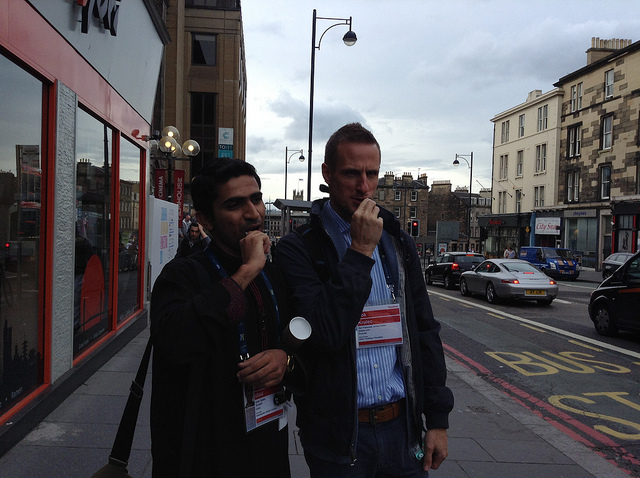<image>What is sold at the bageri? It is not sure what is sold at the bageri. It can be food, bagels, bread or even chapstick. What is sold at the bageri? I don't know what is sold at the bageri. It can be food, bagels, bread or chapstick. 